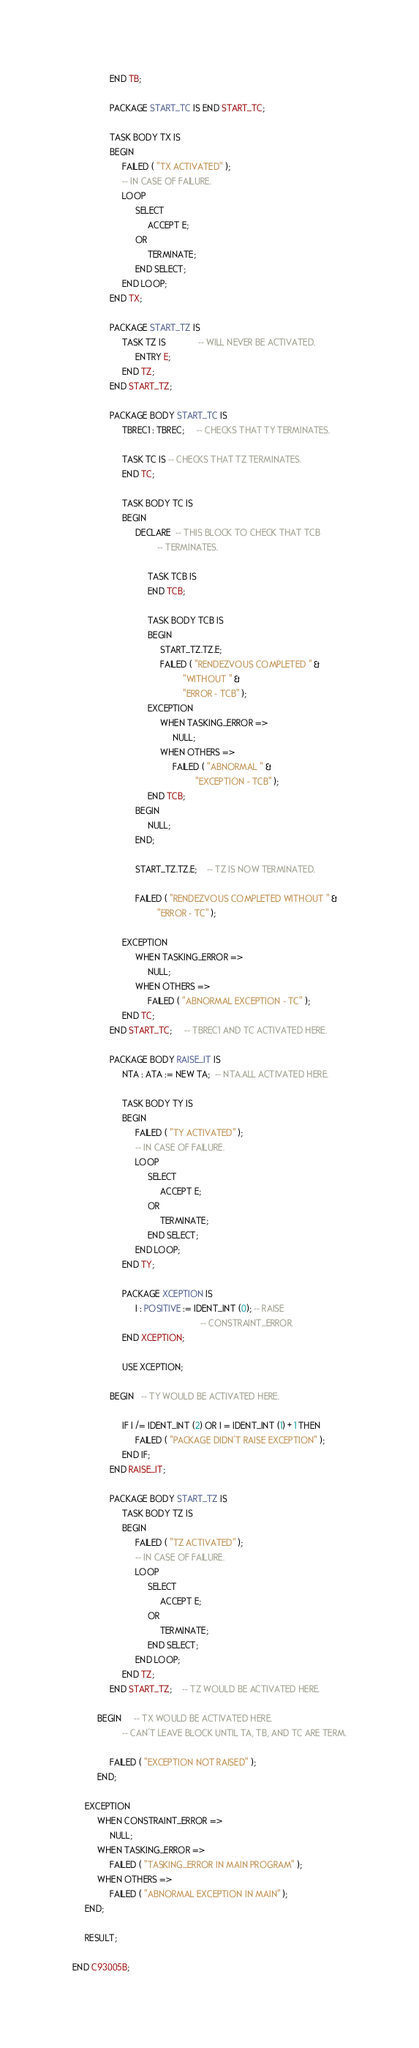Convert code to text. <code><loc_0><loc_0><loc_500><loc_500><_Ada_>               END TB;

               PACKAGE START_TC IS END START_TC;

               TASK BODY TX IS
               BEGIN
                    FAILED ( "TX ACTIVATED" );
                    -- IN CASE OF FAILURE.
                    LOOP
                         SELECT
                              ACCEPT E;
                         OR
                              TERMINATE;
                         END SELECT;
                    END LOOP;
               END TX;

               PACKAGE START_TZ IS
                    TASK TZ IS             -- WILL NEVER BE ACTIVATED.
                         ENTRY E;
                    END TZ;
               END START_TZ;

               PACKAGE BODY START_TC IS
                    TBREC1 : TBREC;     -- CHECKS THAT TY TERMINATES.

                    TASK TC IS -- CHECKS THAT TZ TERMINATES.
                    END TC;
                
                    TASK BODY TC IS
                    BEGIN
                         DECLARE  -- THIS BLOCK TO CHECK THAT TCB 
                                  -- TERMINATES.
 
                              TASK TCB IS
                              END TCB;
          
                              TASK BODY TCB IS
                              BEGIN
                                   START_TZ.TZ.E;
                                   FAILED ( "RENDEZVOUS COMPLETED " &
                                            "WITHOUT " &
                                            "ERROR - TCB" );
                              EXCEPTION
                                   WHEN TASKING_ERROR =>
                                        NULL;
                                   WHEN OTHERS =>
                                        FAILED ( "ABNORMAL " &
                                                 "EXCEPTION - TCB" );
                              END TCB;
                         BEGIN
                              NULL;
                         END;

                         START_TZ.TZ.E;    -- TZ IS NOW TERMINATED.
      
                         FAILED ( "RENDEZVOUS COMPLETED WITHOUT " &
                                  "ERROR - TC" );
      
                    EXCEPTION
                         WHEN TASKING_ERROR =>
                              NULL;
                         WHEN OTHERS =>
                              FAILED ( "ABNORMAL EXCEPTION - TC" );
                    END TC;
               END START_TC;     -- TBREC1 AND TC ACTIVATED HERE.
                     
               PACKAGE BODY RAISE_IT IS
                    NTA : ATA := NEW TA;  -- NTA.ALL ACTIVATED HERE.
 
                    TASK BODY TY IS
                    BEGIN
                         FAILED ( "TY ACTIVATED" );
                         -- IN CASE OF FAILURE.
                         LOOP
                              SELECT
                                   ACCEPT E;
                              OR
                                   TERMINATE;
                              END SELECT;
                         END LOOP;
                    END TY;
 
                    PACKAGE XCEPTION IS
                         I : POSITIVE := IDENT_INT (0); -- RAISE
                                                   -- CONSTRAINT_ERROR.
                    END XCEPTION;
                
                    USE XCEPTION;
 
               BEGIN   -- TY WOULD BE ACTIVATED HERE.

                    IF I /= IDENT_INT (2) OR I = IDENT_INT (1) + 1 THEN
                         FAILED ( "PACKAGE DIDN'T RAISE EXCEPTION" );
                    END IF;
               END RAISE_IT;
 
               PACKAGE BODY START_TZ IS
                    TASK BODY TZ IS
                    BEGIN
                         FAILED ( "TZ ACTIVATED" );
                         -- IN CASE OF FAILURE.
                         LOOP
                              SELECT
                                   ACCEPT E;
                              OR
                                   TERMINATE;
                              END SELECT;
                         END LOOP;
                    END TZ;
               END START_TZ;    -- TZ WOULD BE ACTIVATED HERE.
 
          BEGIN     -- TX WOULD BE ACTIVATED HERE.
                    -- CAN'T LEAVE BLOCK UNTIL TA, TB, AND TC ARE TERM.

               FAILED ( "EXCEPTION NOT RAISED" );
          END;
 
     EXCEPTION
          WHEN CONSTRAINT_ERROR =>
               NULL;
          WHEN TASKING_ERROR =>
               FAILED ( "TASKING_ERROR IN MAIN PROGRAM" );
          WHEN OTHERS =>
               FAILED ( "ABNORMAL EXCEPTION IN MAIN" );
     END;
 
     RESULT;
 
END C93005B;
</code> 